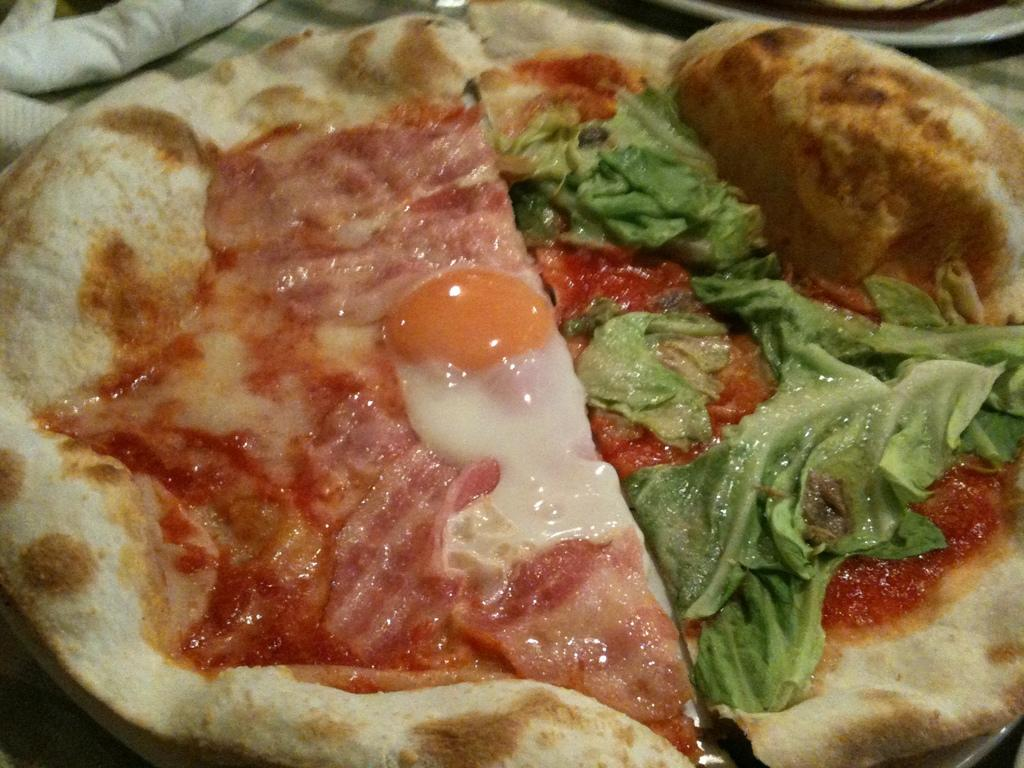What is the main subject in the center of the image? There is a pizza in the center of the image. What can be seen in the background of the image? There is a cloth and a plate in the background of the image. What is the son reading in the image? There is no son or reading activity present in the image. How many sheep can be seen grazing in the background of the image? There are no sheep present in the image. 